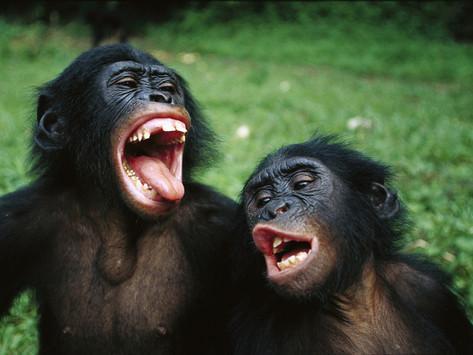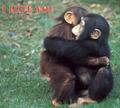The first image is the image on the left, the second image is the image on the right. Given the left and right images, does the statement "At least one ape is showing its teeth." hold true? Answer yes or no. Yes. 